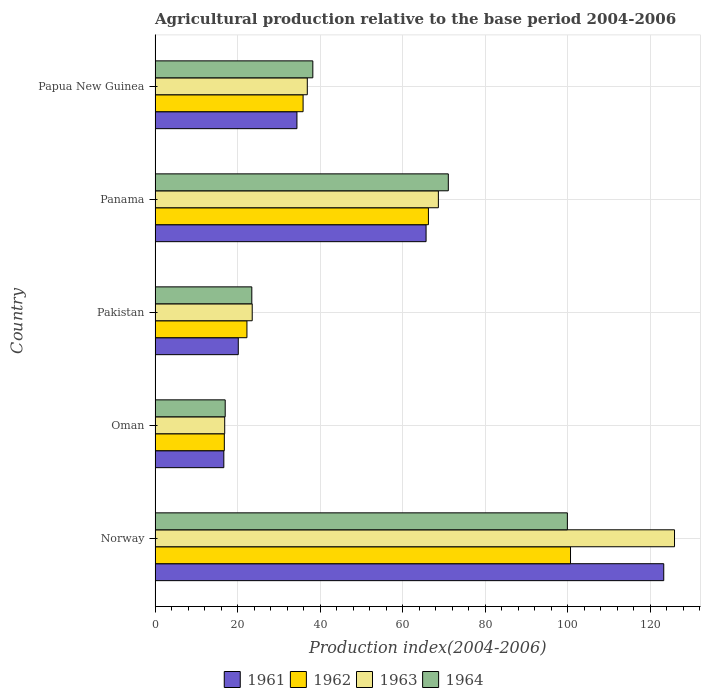How many bars are there on the 4th tick from the bottom?
Ensure brevity in your answer.  4. What is the label of the 4th group of bars from the top?
Ensure brevity in your answer.  Oman. In how many cases, is the number of bars for a given country not equal to the number of legend labels?
Provide a succinct answer. 0. What is the agricultural production index in 1964 in Pakistan?
Your response must be concise. 23.45. Across all countries, what is the maximum agricultural production index in 1963?
Provide a short and direct response. 125.91. Across all countries, what is the minimum agricultural production index in 1961?
Your answer should be compact. 16.67. In which country was the agricultural production index in 1962 maximum?
Your answer should be compact. Norway. In which country was the agricultural production index in 1961 minimum?
Make the answer very short. Oman. What is the total agricultural production index in 1961 in the graph?
Provide a short and direct response. 260.22. What is the difference between the agricultural production index in 1963 in Oman and that in Papua New Guinea?
Give a very brief answer. -20.02. What is the difference between the agricultural production index in 1961 in Papua New Guinea and the agricultural production index in 1964 in Oman?
Offer a terse response. 17.39. What is the average agricultural production index in 1964 per country?
Keep it short and to the point. 49.94. What is the difference between the agricultural production index in 1963 and agricultural production index in 1962 in Pakistan?
Offer a terse response. 1.28. In how many countries, is the agricultural production index in 1963 greater than 104 ?
Offer a very short reply. 1. What is the ratio of the agricultural production index in 1964 in Norway to that in Oman?
Make the answer very short. 5.88. Is the agricultural production index in 1963 in Norway less than that in Papua New Guinea?
Your answer should be very brief. No. What is the difference between the highest and the second highest agricultural production index in 1964?
Keep it short and to the point. 28.86. What is the difference between the highest and the lowest agricultural production index in 1963?
Your answer should be compact. 109.03. Is it the case that in every country, the sum of the agricultural production index in 1964 and agricultural production index in 1962 is greater than the sum of agricultural production index in 1961 and agricultural production index in 1963?
Provide a short and direct response. No. What does the 4th bar from the top in Norway represents?
Keep it short and to the point. 1961. Is it the case that in every country, the sum of the agricultural production index in 1964 and agricultural production index in 1963 is greater than the agricultural production index in 1961?
Make the answer very short. Yes. Does the graph contain any zero values?
Your response must be concise. No. Does the graph contain grids?
Keep it short and to the point. Yes. Where does the legend appear in the graph?
Offer a very short reply. Bottom center. What is the title of the graph?
Provide a succinct answer. Agricultural production relative to the base period 2004-2006. Does "1989" appear as one of the legend labels in the graph?
Offer a terse response. No. What is the label or title of the X-axis?
Your answer should be very brief. Production index(2004-2006). What is the label or title of the Y-axis?
Your response must be concise. Country. What is the Production index(2004-2006) in 1961 in Norway?
Offer a terse response. 123.3. What is the Production index(2004-2006) of 1962 in Norway?
Your answer should be compact. 100.7. What is the Production index(2004-2006) in 1963 in Norway?
Make the answer very short. 125.91. What is the Production index(2004-2006) of 1964 in Norway?
Provide a succinct answer. 99.94. What is the Production index(2004-2006) in 1961 in Oman?
Give a very brief answer. 16.67. What is the Production index(2004-2006) in 1962 in Oman?
Your response must be concise. 16.79. What is the Production index(2004-2006) in 1963 in Oman?
Make the answer very short. 16.88. What is the Production index(2004-2006) in 1964 in Oman?
Your answer should be very brief. 17. What is the Production index(2004-2006) in 1961 in Pakistan?
Give a very brief answer. 20.17. What is the Production index(2004-2006) of 1962 in Pakistan?
Provide a succinct answer. 22.27. What is the Production index(2004-2006) in 1963 in Pakistan?
Keep it short and to the point. 23.55. What is the Production index(2004-2006) in 1964 in Pakistan?
Make the answer very short. 23.45. What is the Production index(2004-2006) of 1961 in Panama?
Provide a succinct answer. 65.69. What is the Production index(2004-2006) in 1962 in Panama?
Give a very brief answer. 66.26. What is the Production index(2004-2006) in 1963 in Panama?
Make the answer very short. 68.67. What is the Production index(2004-2006) of 1964 in Panama?
Your answer should be compact. 71.08. What is the Production index(2004-2006) in 1961 in Papua New Guinea?
Ensure brevity in your answer.  34.39. What is the Production index(2004-2006) of 1962 in Papua New Guinea?
Keep it short and to the point. 35.88. What is the Production index(2004-2006) in 1963 in Papua New Guinea?
Your answer should be very brief. 36.9. What is the Production index(2004-2006) in 1964 in Papua New Guinea?
Offer a very short reply. 38.24. Across all countries, what is the maximum Production index(2004-2006) of 1961?
Make the answer very short. 123.3. Across all countries, what is the maximum Production index(2004-2006) of 1962?
Provide a succinct answer. 100.7. Across all countries, what is the maximum Production index(2004-2006) in 1963?
Offer a terse response. 125.91. Across all countries, what is the maximum Production index(2004-2006) in 1964?
Your answer should be compact. 99.94. Across all countries, what is the minimum Production index(2004-2006) of 1961?
Your answer should be compact. 16.67. Across all countries, what is the minimum Production index(2004-2006) in 1962?
Give a very brief answer. 16.79. Across all countries, what is the minimum Production index(2004-2006) in 1963?
Your response must be concise. 16.88. Across all countries, what is the minimum Production index(2004-2006) of 1964?
Your answer should be very brief. 17. What is the total Production index(2004-2006) in 1961 in the graph?
Offer a very short reply. 260.22. What is the total Production index(2004-2006) in 1962 in the graph?
Make the answer very short. 241.9. What is the total Production index(2004-2006) of 1963 in the graph?
Your answer should be compact. 271.91. What is the total Production index(2004-2006) of 1964 in the graph?
Keep it short and to the point. 249.71. What is the difference between the Production index(2004-2006) of 1961 in Norway and that in Oman?
Keep it short and to the point. 106.63. What is the difference between the Production index(2004-2006) of 1962 in Norway and that in Oman?
Offer a terse response. 83.91. What is the difference between the Production index(2004-2006) in 1963 in Norway and that in Oman?
Provide a short and direct response. 109.03. What is the difference between the Production index(2004-2006) of 1964 in Norway and that in Oman?
Offer a very short reply. 82.94. What is the difference between the Production index(2004-2006) of 1961 in Norway and that in Pakistan?
Keep it short and to the point. 103.13. What is the difference between the Production index(2004-2006) in 1962 in Norway and that in Pakistan?
Provide a succinct answer. 78.43. What is the difference between the Production index(2004-2006) of 1963 in Norway and that in Pakistan?
Offer a very short reply. 102.36. What is the difference between the Production index(2004-2006) of 1964 in Norway and that in Pakistan?
Offer a very short reply. 76.49. What is the difference between the Production index(2004-2006) in 1961 in Norway and that in Panama?
Provide a short and direct response. 57.61. What is the difference between the Production index(2004-2006) of 1962 in Norway and that in Panama?
Ensure brevity in your answer.  34.44. What is the difference between the Production index(2004-2006) in 1963 in Norway and that in Panama?
Ensure brevity in your answer.  57.24. What is the difference between the Production index(2004-2006) in 1964 in Norway and that in Panama?
Your response must be concise. 28.86. What is the difference between the Production index(2004-2006) in 1961 in Norway and that in Papua New Guinea?
Offer a very short reply. 88.91. What is the difference between the Production index(2004-2006) of 1962 in Norway and that in Papua New Guinea?
Your answer should be compact. 64.82. What is the difference between the Production index(2004-2006) of 1963 in Norway and that in Papua New Guinea?
Give a very brief answer. 89.01. What is the difference between the Production index(2004-2006) of 1964 in Norway and that in Papua New Guinea?
Provide a short and direct response. 61.7. What is the difference between the Production index(2004-2006) of 1962 in Oman and that in Pakistan?
Your answer should be very brief. -5.48. What is the difference between the Production index(2004-2006) in 1963 in Oman and that in Pakistan?
Offer a very short reply. -6.67. What is the difference between the Production index(2004-2006) in 1964 in Oman and that in Pakistan?
Your answer should be very brief. -6.45. What is the difference between the Production index(2004-2006) of 1961 in Oman and that in Panama?
Your answer should be very brief. -49.02. What is the difference between the Production index(2004-2006) in 1962 in Oman and that in Panama?
Ensure brevity in your answer.  -49.47. What is the difference between the Production index(2004-2006) in 1963 in Oman and that in Panama?
Your answer should be very brief. -51.79. What is the difference between the Production index(2004-2006) of 1964 in Oman and that in Panama?
Ensure brevity in your answer.  -54.08. What is the difference between the Production index(2004-2006) in 1961 in Oman and that in Papua New Guinea?
Offer a very short reply. -17.72. What is the difference between the Production index(2004-2006) in 1962 in Oman and that in Papua New Guinea?
Ensure brevity in your answer.  -19.09. What is the difference between the Production index(2004-2006) of 1963 in Oman and that in Papua New Guinea?
Make the answer very short. -20.02. What is the difference between the Production index(2004-2006) in 1964 in Oman and that in Papua New Guinea?
Ensure brevity in your answer.  -21.24. What is the difference between the Production index(2004-2006) in 1961 in Pakistan and that in Panama?
Keep it short and to the point. -45.52. What is the difference between the Production index(2004-2006) in 1962 in Pakistan and that in Panama?
Your answer should be compact. -43.99. What is the difference between the Production index(2004-2006) in 1963 in Pakistan and that in Panama?
Provide a succinct answer. -45.12. What is the difference between the Production index(2004-2006) in 1964 in Pakistan and that in Panama?
Your answer should be compact. -47.63. What is the difference between the Production index(2004-2006) of 1961 in Pakistan and that in Papua New Guinea?
Your answer should be very brief. -14.22. What is the difference between the Production index(2004-2006) of 1962 in Pakistan and that in Papua New Guinea?
Provide a succinct answer. -13.61. What is the difference between the Production index(2004-2006) in 1963 in Pakistan and that in Papua New Guinea?
Provide a short and direct response. -13.35. What is the difference between the Production index(2004-2006) of 1964 in Pakistan and that in Papua New Guinea?
Give a very brief answer. -14.79. What is the difference between the Production index(2004-2006) in 1961 in Panama and that in Papua New Guinea?
Make the answer very short. 31.3. What is the difference between the Production index(2004-2006) of 1962 in Panama and that in Papua New Guinea?
Provide a short and direct response. 30.38. What is the difference between the Production index(2004-2006) of 1963 in Panama and that in Papua New Guinea?
Your response must be concise. 31.77. What is the difference between the Production index(2004-2006) in 1964 in Panama and that in Papua New Guinea?
Ensure brevity in your answer.  32.84. What is the difference between the Production index(2004-2006) of 1961 in Norway and the Production index(2004-2006) of 1962 in Oman?
Provide a succinct answer. 106.51. What is the difference between the Production index(2004-2006) of 1961 in Norway and the Production index(2004-2006) of 1963 in Oman?
Ensure brevity in your answer.  106.42. What is the difference between the Production index(2004-2006) in 1961 in Norway and the Production index(2004-2006) in 1964 in Oman?
Provide a succinct answer. 106.3. What is the difference between the Production index(2004-2006) in 1962 in Norway and the Production index(2004-2006) in 1963 in Oman?
Your answer should be compact. 83.82. What is the difference between the Production index(2004-2006) of 1962 in Norway and the Production index(2004-2006) of 1964 in Oman?
Your answer should be very brief. 83.7. What is the difference between the Production index(2004-2006) in 1963 in Norway and the Production index(2004-2006) in 1964 in Oman?
Your answer should be very brief. 108.91. What is the difference between the Production index(2004-2006) of 1961 in Norway and the Production index(2004-2006) of 1962 in Pakistan?
Offer a terse response. 101.03. What is the difference between the Production index(2004-2006) of 1961 in Norway and the Production index(2004-2006) of 1963 in Pakistan?
Your response must be concise. 99.75. What is the difference between the Production index(2004-2006) of 1961 in Norway and the Production index(2004-2006) of 1964 in Pakistan?
Give a very brief answer. 99.85. What is the difference between the Production index(2004-2006) in 1962 in Norway and the Production index(2004-2006) in 1963 in Pakistan?
Keep it short and to the point. 77.15. What is the difference between the Production index(2004-2006) in 1962 in Norway and the Production index(2004-2006) in 1964 in Pakistan?
Provide a short and direct response. 77.25. What is the difference between the Production index(2004-2006) of 1963 in Norway and the Production index(2004-2006) of 1964 in Pakistan?
Your response must be concise. 102.46. What is the difference between the Production index(2004-2006) of 1961 in Norway and the Production index(2004-2006) of 1962 in Panama?
Ensure brevity in your answer.  57.04. What is the difference between the Production index(2004-2006) of 1961 in Norway and the Production index(2004-2006) of 1963 in Panama?
Your response must be concise. 54.63. What is the difference between the Production index(2004-2006) in 1961 in Norway and the Production index(2004-2006) in 1964 in Panama?
Provide a succinct answer. 52.22. What is the difference between the Production index(2004-2006) of 1962 in Norway and the Production index(2004-2006) of 1963 in Panama?
Ensure brevity in your answer.  32.03. What is the difference between the Production index(2004-2006) in 1962 in Norway and the Production index(2004-2006) in 1964 in Panama?
Ensure brevity in your answer.  29.62. What is the difference between the Production index(2004-2006) of 1963 in Norway and the Production index(2004-2006) of 1964 in Panama?
Give a very brief answer. 54.83. What is the difference between the Production index(2004-2006) of 1961 in Norway and the Production index(2004-2006) of 1962 in Papua New Guinea?
Your response must be concise. 87.42. What is the difference between the Production index(2004-2006) of 1961 in Norway and the Production index(2004-2006) of 1963 in Papua New Guinea?
Your response must be concise. 86.4. What is the difference between the Production index(2004-2006) of 1961 in Norway and the Production index(2004-2006) of 1964 in Papua New Guinea?
Ensure brevity in your answer.  85.06. What is the difference between the Production index(2004-2006) in 1962 in Norway and the Production index(2004-2006) in 1963 in Papua New Guinea?
Provide a short and direct response. 63.8. What is the difference between the Production index(2004-2006) in 1962 in Norway and the Production index(2004-2006) in 1964 in Papua New Guinea?
Your answer should be very brief. 62.46. What is the difference between the Production index(2004-2006) of 1963 in Norway and the Production index(2004-2006) of 1964 in Papua New Guinea?
Your response must be concise. 87.67. What is the difference between the Production index(2004-2006) in 1961 in Oman and the Production index(2004-2006) in 1963 in Pakistan?
Ensure brevity in your answer.  -6.88. What is the difference between the Production index(2004-2006) in 1961 in Oman and the Production index(2004-2006) in 1964 in Pakistan?
Make the answer very short. -6.78. What is the difference between the Production index(2004-2006) of 1962 in Oman and the Production index(2004-2006) of 1963 in Pakistan?
Offer a very short reply. -6.76. What is the difference between the Production index(2004-2006) in 1962 in Oman and the Production index(2004-2006) in 1964 in Pakistan?
Provide a succinct answer. -6.66. What is the difference between the Production index(2004-2006) of 1963 in Oman and the Production index(2004-2006) of 1964 in Pakistan?
Provide a succinct answer. -6.57. What is the difference between the Production index(2004-2006) in 1961 in Oman and the Production index(2004-2006) in 1962 in Panama?
Offer a very short reply. -49.59. What is the difference between the Production index(2004-2006) of 1961 in Oman and the Production index(2004-2006) of 1963 in Panama?
Provide a short and direct response. -52. What is the difference between the Production index(2004-2006) in 1961 in Oman and the Production index(2004-2006) in 1964 in Panama?
Your response must be concise. -54.41. What is the difference between the Production index(2004-2006) of 1962 in Oman and the Production index(2004-2006) of 1963 in Panama?
Your answer should be very brief. -51.88. What is the difference between the Production index(2004-2006) in 1962 in Oman and the Production index(2004-2006) in 1964 in Panama?
Keep it short and to the point. -54.29. What is the difference between the Production index(2004-2006) in 1963 in Oman and the Production index(2004-2006) in 1964 in Panama?
Your response must be concise. -54.2. What is the difference between the Production index(2004-2006) in 1961 in Oman and the Production index(2004-2006) in 1962 in Papua New Guinea?
Provide a succinct answer. -19.21. What is the difference between the Production index(2004-2006) in 1961 in Oman and the Production index(2004-2006) in 1963 in Papua New Guinea?
Provide a short and direct response. -20.23. What is the difference between the Production index(2004-2006) in 1961 in Oman and the Production index(2004-2006) in 1964 in Papua New Guinea?
Ensure brevity in your answer.  -21.57. What is the difference between the Production index(2004-2006) of 1962 in Oman and the Production index(2004-2006) of 1963 in Papua New Guinea?
Offer a very short reply. -20.11. What is the difference between the Production index(2004-2006) of 1962 in Oman and the Production index(2004-2006) of 1964 in Papua New Guinea?
Keep it short and to the point. -21.45. What is the difference between the Production index(2004-2006) of 1963 in Oman and the Production index(2004-2006) of 1964 in Papua New Guinea?
Your answer should be compact. -21.36. What is the difference between the Production index(2004-2006) of 1961 in Pakistan and the Production index(2004-2006) of 1962 in Panama?
Your answer should be very brief. -46.09. What is the difference between the Production index(2004-2006) of 1961 in Pakistan and the Production index(2004-2006) of 1963 in Panama?
Give a very brief answer. -48.5. What is the difference between the Production index(2004-2006) in 1961 in Pakistan and the Production index(2004-2006) in 1964 in Panama?
Your response must be concise. -50.91. What is the difference between the Production index(2004-2006) of 1962 in Pakistan and the Production index(2004-2006) of 1963 in Panama?
Provide a succinct answer. -46.4. What is the difference between the Production index(2004-2006) in 1962 in Pakistan and the Production index(2004-2006) in 1964 in Panama?
Offer a very short reply. -48.81. What is the difference between the Production index(2004-2006) of 1963 in Pakistan and the Production index(2004-2006) of 1964 in Panama?
Your answer should be compact. -47.53. What is the difference between the Production index(2004-2006) in 1961 in Pakistan and the Production index(2004-2006) in 1962 in Papua New Guinea?
Provide a succinct answer. -15.71. What is the difference between the Production index(2004-2006) in 1961 in Pakistan and the Production index(2004-2006) in 1963 in Papua New Guinea?
Offer a terse response. -16.73. What is the difference between the Production index(2004-2006) of 1961 in Pakistan and the Production index(2004-2006) of 1964 in Papua New Guinea?
Ensure brevity in your answer.  -18.07. What is the difference between the Production index(2004-2006) of 1962 in Pakistan and the Production index(2004-2006) of 1963 in Papua New Guinea?
Provide a short and direct response. -14.63. What is the difference between the Production index(2004-2006) of 1962 in Pakistan and the Production index(2004-2006) of 1964 in Papua New Guinea?
Your answer should be very brief. -15.97. What is the difference between the Production index(2004-2006) of 1963 in Pakistan and the Production index(2004-2006) of 1964 in Papua New Guinea?
Give a very brief answer. -14.69. What is the difference between the Production index(2004-2006) of 1961 in Panama and the Production index(2004-2006) of 1962 in Papua New Guinea?
Make the answer very short. 29.81. What is the difference between the Production index(2004-2006) of 1961 in Panama and the Production index(2004-2006) of 1963 in Papua New Guinea?
Give a very brief answer. 28.79. What is the difference between the Production index(2004-2006) in 1961 in Panama and the Production index(2004-2006) in 1964 in Papua New Guinea?
Ensure brevity in your answer.  27.45. What is the difference between the Production index(2004-2006) in 1962 in Panama and the Production index(2004-2006) in 1963 in Papua New Guinea?
Ensure brevity in your answer.  29.36. What is the difference between the Production index(2004-2006) in 1962 in Panama and the Production index(2004-2006) in 1964 in Papua New Guinea?
Keep it short and to the point. 28.02. What is the difference between the Production index(2004-2006) in 1963 in Panama and the Production index(2004-2006) in 1964 in Papua New Guinea?
Provide a short and direct response. 30.43. What is the average Production index(2004-2006) in 1961 per country?
Your answer should be very brief. 52.04. What is the average Production index(2004-2006) of 1962 per country?
Ensure brevity in your answer.  48.38. What is the average Production index(2004-2006) of 1963 per country?
Provide a short and direct response. 54.38. What is the average Production index(2004-2006) of 1964 per country?
Ensure brevity in your answer.  49.94. What is the difference between the Production index(2004-2006) of 1961 and Production index(2004-2006) of 1962 in Norway?
Give a very brief answer. 22.6. What is the difference between the Production index(2004-2006) of 1961 and Production index(2004-2006) of 1963 in Norway?
Your answer should be very brief. -2.61. What is the difference between the Production index(2004-2006) of 1961 and Production index(2004-2006) of 1964 in Norway?
Ensure brevity in your answer.  23.36. What is the difference between the Production index(2004-2006) of 1962 and Production index(2004-2006) of 1963 in Norway?
Your response must be concise. -25.21. What is the difference between the Production index(2004-2006) in 1962 and Production index(2004-2006) in 1964 in Norway?
Offer a very short reply. 0.76. What is the difference between the Production index(2004-2006) in 1963 and Production index(2004-2006) in 1964 in Norway?
Offer a very short reply. 25.97. What is the difference between the Production index(2004-2006) of 1961 and Production index(2004-2006) of 1962 in Oman?
Provide a short and direct response. -0.12. What is the difference between the Production index(2004-2006) in 1961 and Production index(2004-2006) in 1963 in Oman?
Offer a terse response. -0.21. What is the difference between the Production index(2004-2006) in 1961 and Production index(2004-2006) in 1964 in Oman?
Ensure brevity in your answer.  -0.33. What is the difference between the Production index(2004-2006) of 1962 and Production index(2004-2006) of 1963 in Oman?
Your answer should be compact. -0.09. What is the difference between the Production index(2004-2006) in 1962 and Production index(2004-2006) in 1964 in Oman?
Provide a short and direct response. -0.21. What is the difference between the Production index(2004-2006) in 1963 and Production index(2004-2006) in 1964 in Oman?
Keep it short and to the point. -0.12. What is the difference between the Production index(2004-2006) of 1961 and Production index(2004-2006) of 1963 in Pakistan?
Offer a very short reply. -3.38. What is the difference between the Production index(2004-2006) of 1961 and Production index(2004-2006) of 1964 in Pakistan?
Give a very brief answer. -3.28. What is the difference between the Production index(2004-2006) in 1962 and Production index(2004-2006) in 1963 in Pakistan?
Your response must be concise. -1.28. What is the difference between the Production index(2004-2006) of 1962 and Production index(2004-2006) of 1964 in Pakistan?
Offer a very short reply. -1.18. What is the difference between the Production index(2004-2006) of 1963 and Production index(2004-2006) of 1964 in Pakistan?
Provide a succinct answer. 0.1. What is the difference between the Production index(2004-2006) of 1961 and Production index(2004-2006) of 1962 in Panama?
Offer a terse response. -0.57. What is the difference between the Production index(2004-2006) of 1961 and Production index(2004-2006) of 1963 in Panama?
Keep it short and to the point. -2.98. What is the difference between the Production index(2004-2006) of 1961 and Production index(2004-2006) of 1964 in Panama?
Keep it short and to the point. -5.39. What is the difference between the Production index(2004-2006) in 1962 and Production index(2004-2006) in 1963 in Panama?
Ensure brevity in your answer.  -2.41. What is the difference between the Production index(2004-2006) of 1962 and Production index(2004-2006) of 1964 in Panama?
Offer a terse response. -4.82. What is the difference between the Production index(2004-2006) in 1963 and Production index(2004-2006) in 1964 in Panama?
Keep it short and to the point. -2.41. What is the difference between the Production index(2004-2006) of 1961 and Production index(2004-2006) of 1962 in Papua New Guinea?
Your answer should be very brief. -1.49. What is the difference between the Production index(2004-2006) of 1961 and Production index(2004-2006) of 1963 in Papua New Guinea?
Keep it short and to the point. -2.51. What is the difference between the Production index(2004-2006) of 1961 and Production index(2004-2006) of 1964 in Papua New Guinea?
Your response must be concise. -3.85. What is the difference between the Production index(2004-2006) in 1962 and Production index(2004-2006) in 1963 in Papua New Guinea?
Your response must be concise. -1.02. What is the difference between the Production index(2004-2006) of 1962 and Production index(2004-2006) of 1964 in Papua New Guinea?
Offer a terse response. -2.36. What is the difference between the Production index(2004-2006) of 1963 and Production index(2004-2006) of 1964 in Papua New Guinea?
Provide a short and direct response. -1.34. What is the ratio of the Production index(2004-2006) of 1961 in Norway to that in Oman?
Provide a succinct answer. 7.4. What is the ratio of the Production index(2004-2006) of 1962 in Norway to that in Oman?
Offer a very short reply. 6. What is the ratio of the Production index(2004-2006) in 1963 in Norway to that in Oman?
Make the answer very short. 7.46. What is the ratio of the Production index(2004-2006) of 1964 in Norway to that in Oman?
Give a very brief answer. 5.88. What is the ratio of the Production index(2004-2006) of 1961 in Norway to that in Pakistan?
Your answer should be very brief. 6.11. What is the ratio of the Production index(2004-2006) in 1962 in Norway to that in Pakistan?
Your response must be concise. 4.52. What is the ratio of the Production index(2004-2006) of 1963 in Norway to that in Pakistan?
Provide a succinct answer. 5.35. What is the ratio of the Production index(2004-2006) of 1964 in Norway to that in Pakistan?
Provide a succinct answer. 4.26. What is the ratio of the Production index(2004-2006) in 1961 in Norway to that in Panama?
Your response must be concise. 1.88. What is the ratio of the Production index(2004-2006) of 1962 in Norway to that in Panama?
Offer a very short reply. 1.52. What is the ratio of the Production index(2004-2006) of 1963 in Norway to that in Panama?
Ensure brevity in your answer.  1.83. What is the ratio of the Production index(2004-2006) in 1964 in Norway to that in Panama?
Provide a short and direct response. 1.41. What is the ratio of the Production index(2004-2006) in 1961 in Norway to that in Papua New Guinea?
Your answer should be compact. 3.59. What is the ratio of the Production index(2004-2006) in 1962 in Norway to that in Papua New Guinea?
Provide a succinct answer. 2.81. What is the ratio of the Production index(2004-2006) of 1963 in Norway to that in Papua New Guinea?
Your answer should be very brief. 3.41. What is the ratio of the Production index(2004-2006) in 1964 in Norway to that in Papua New Guinea?
Provide a succinct answer. 2.61. What is the ratio of the Production index(2004-2006) of 1961 in Oman to that in Pakistan?
Offer a terse response. 0.83. What is the ratio of the Production index(2004-2006) of 1962 in Oman to that in Pakistan?
Give a very brief answer. 0.75. What is the ratio of the Production index(2004-2006) of 1963 in Oman to that in Pakistan?
Your answer should be very brief. 0.72. What is the ratio of the Production index(2004-2006) of 1964 in Oman to that in Pakistan?
Your response must be concise. 0.72. What is the ratio of the Production index(2004-2006) of 1961 in Oman to that in Panama?
Keep it short and to the point. 0.25. What is the ratio of the Production index(2004-2006) in 1962 in Oman to that in Panama?
Your response must be concise. 0.25. What is the ratio of the Production index(2004-2006) of 1963 in Oman to that in Panama?
Your response must be concise. 0.25. What is the ratio of the Production index(2004-2006) of 1964 in Oman to that in Panama?
Your answer should be compact. 0.24. What is the ratio of the Production index(2004-2006) in 1961 in Oman to that in Papua New Guinea?
Your answer should be very brief. 0.48. What is the ratio of the Production index(2004-2006) of 1962 in Oman to that in Papua New Guinea?
Offer a very short reply. 0.47. What is the ratio of the Production index(2004-2006) in 1963 in Oman to that in Papua New Guinea?
Make the answer very short. 0.46. What is the ratio of the Production index(2004-2006) of 1964 in Oman to that in Papua New Guinea?
Provide a short and direct response. 0.44. What is the ratio of the Production index(2004-2006) of 1961 in Pakistan to that in Panama?
Offer a terse response. 0.31. What is the ratio of the Production index(2004-2006) in 1962 in Pakistan to that in Panama?
Keep it short and to the point. 0.34. What is the ratio of the Production index(2004-2006) in 1963 in Pakistan to that in Panama?
Ensure brevity in your answer.  0.34. What is the ratio of the Production index(2004-2006) in 1964 in Pakistan to that in Panama?
Your response must be concise. 0.33. What is the ratio of the Production index(2004-2006) of 1961 in Pakistan to that in Papua New Guinea?
Your answer should be very brief. 0.59. What is the ratio of the Production index(2004-2006) in 1962 in Pakistan to that in Papua New Guinea?
Keep it short and to the point. 0.62. What is the ratio of the Production index(2004-2006) in 1963 in Pakistan to that in Papua New Guinea?
Your answer should be compact. 0.64. What is the ratio of the Production index(2004-2006) of 1964 in Pakistan to that in Papua New Guinea?
Give a very brief answer. 0.61. What is the ratio of the Production index(2004-2006) of 1961 in Panama to that in Papua New Guinea?
Make the answer very short. 1.91. What is the ratio of the Production index(2004-2006) in 1962 in Panama to that in Papua New Guinea?
Your response must be concise. 1.85. What is the ratio of the Production index(2004-2006) in 1963 in Panama to that in Papua New Guinea?
Keep it short and to the point. 1.86. What is the ratio of the Production index(2004-2006) in 1964 in Panama to that in Papua New Guinea?
Make the answer very short. 1.86. What is the difference between the highest and the second highest Production index(2004-2006) in 1961?
Give a very brief answer. 57.61. What is the difference between the highest and the second highest Production index(2004-2006) of 1962?
Provide a short and direct response. 34.44. What is the difference between the highest and the second highest Production index(2004-2006) of 1963?
Keep it short and to the point. 57.24. What is the difference between the highest and the second highest Production index(2004-2006) of 1964?
Give a very brief answer. 28.86. What is the difference between the highest and the lowest Production index(2004-2006) in 1961?
Offer a very short reply. 106.63. What is the difference between the highest and the lowest Production index(2004-2006) of 1962?
Provide a short and direct response. 83.91. What is the difference between the highest and the lowest Production index(2004-2006) in 1963?
Keep it short and to the point. 109.03. What is the difference between the highest and the lowest Production index(2004-2006) in 1964?
Provide a short and direct response. 82.94. 